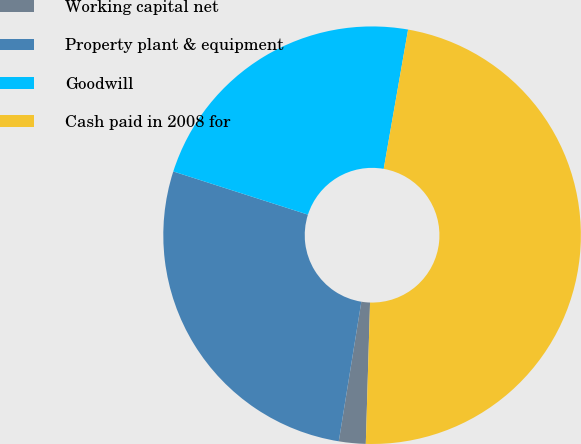Convert chart to OTSL. <chart><loc_0><loc_0><loc_500><loc_500><pie_chart><fcel>Working capital net<fcel>Property plant & equipment<fcel>Goodwill<fcel>Cash paid in 2008 for<nl><fcel>2.07%<fcel>27.39%<fcel>22.82%<fcel>47.72%<nl></chart> 